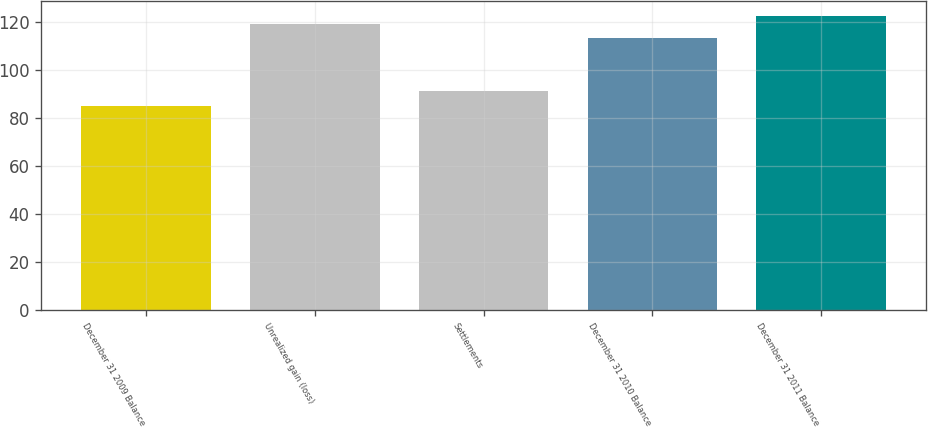Convert chart to OTSL. <chart><loc_0><loc_0><loc_500><loc_500><bar_chart><fcel>December 31 2009 Balance<fcel>Unrealized gain (loss)<fcel>Settlements<fcel>December 31 2010 Balance<fcel>December 31 2011 Balance<nl><fcel>85<fcel>119<fcel>91<fcel>113<fcel>122.5<nl></chart> 